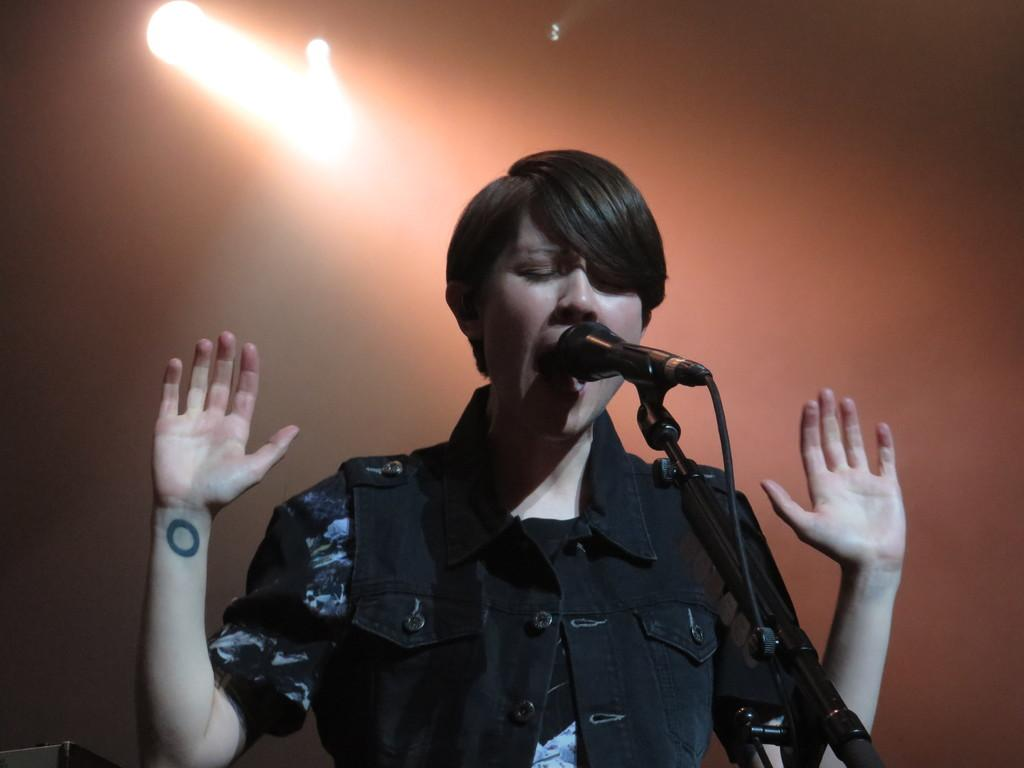What is the person in the image doing? The person is singing into a microphone. What is connected to the microphone? There is a cable associated with the microphone. What can be seen at the top of the image? Focus lights are visible at the top of the image. What type of creature is singing along with the person in the image? There is no creature present in the image; it only features a person singing into a microphone. What is the condition of the person's throat in the image? The image does not provide any information about the person's throat, so it cannot be determined from the image. 